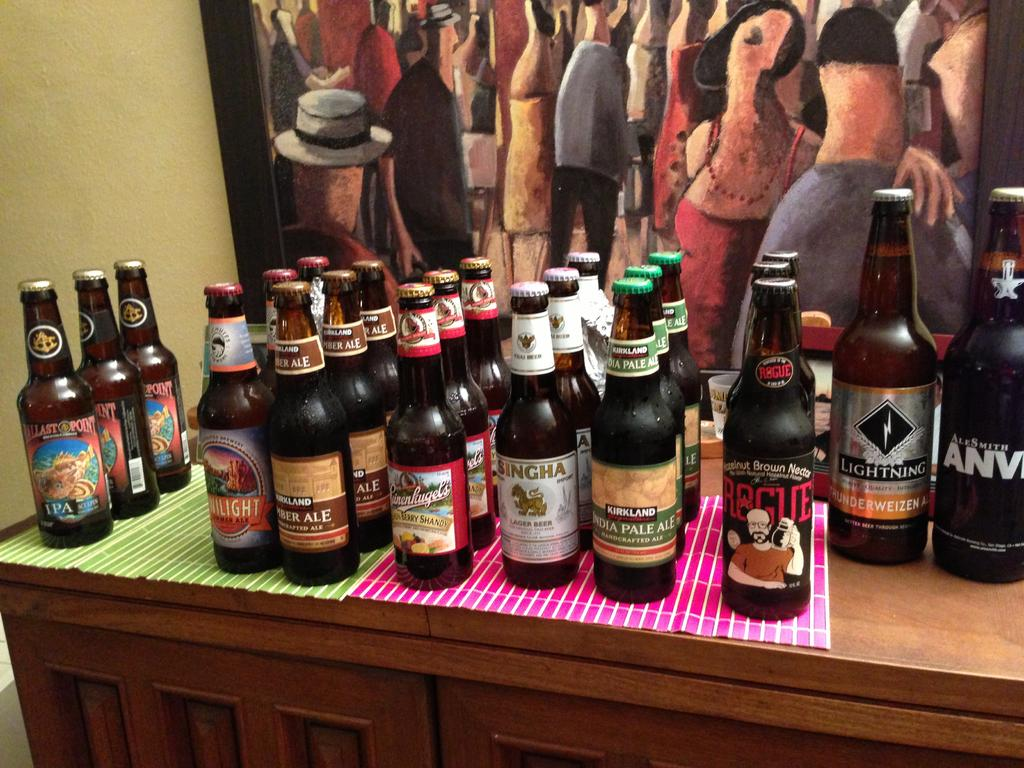Provide a one-sentence caption for the provided image. The brand of beer on the far left is Ballast Point. 